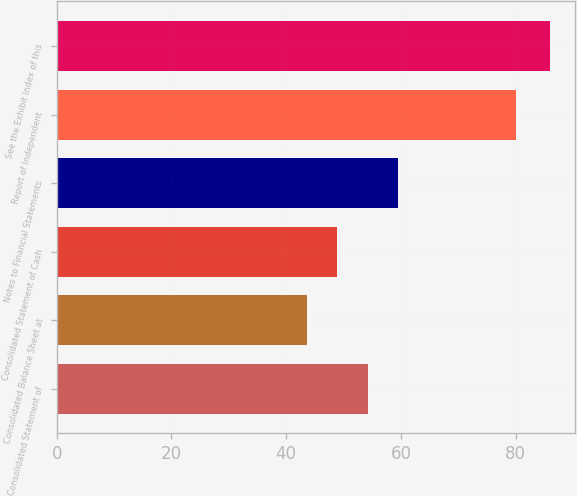Convert chart to OTSL. <chart><loc_0><loc_0><loc_500><loc_500><bar_chart><fcel>Consolidated Statement of<fcel>Consolidated Balance Sheet at<fcel>Consolidated Statement of Cash<fcel>Notes to Financial Statements<fcel>Report of Independent<fcel>See the Exhibit Index of this<nl><fcel>54.2<fcel>43.6<fcel>48.9<fcel>59.5<fcel>80<fcel>86<nl></chart> 